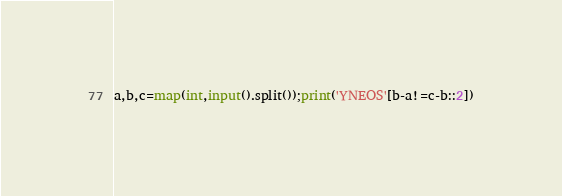Convert code to text. <code><loc_0><loc_0><loc_500><loc_500><_Python_>a,b,c=map(int,input().split());print('YNEOS'[b-a!=c-b::2])</code> 